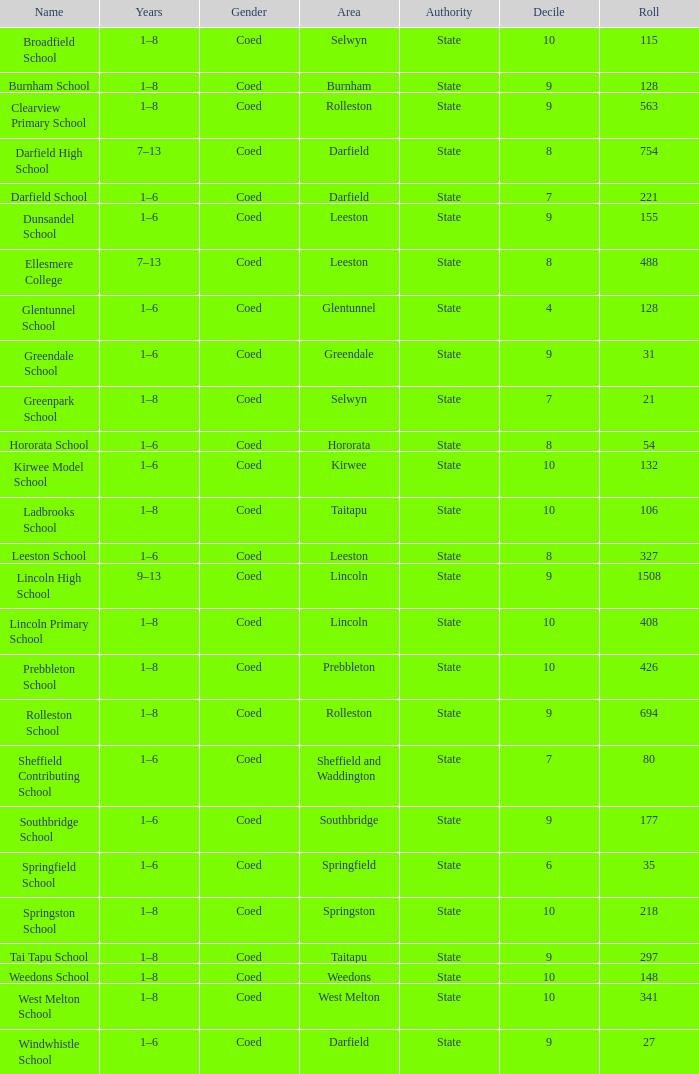During which years is there a name for ladbrooks school? 1–8. 